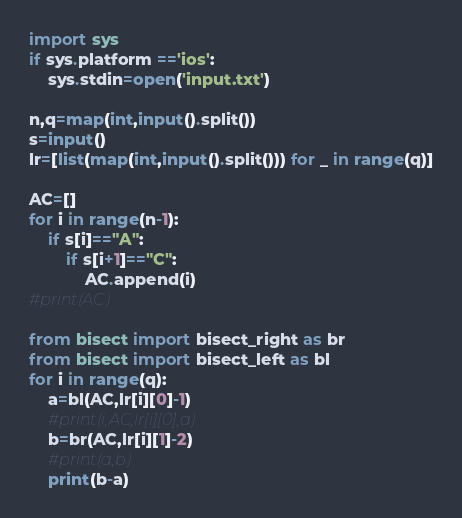<code> <loc_0><loc_0><loc_500><loc_500><_Python_>import sys
if sys.platform =='ios':
	sys.stdin=open('input.txt')

n,q=map(int,input().split())
s=input()
lr=[list(map(int,input().split())) for _ in range(q)]

AC=[]
for i in range(n-1):
    if s[i]=="A":
        if s[i+1]=="C":
            AC.append(i)
#print(AC)

from bisect import bisect_right as br
from bisect import bisect_left as bl
for i in range(q):
    a=bl(AC,lr[i][0]-1)
    #print(i,AC,lr[i][0],a)
    b=br(AC,lr[i][1]-2)
    #print(a,b)
    print(b-a)</code> 